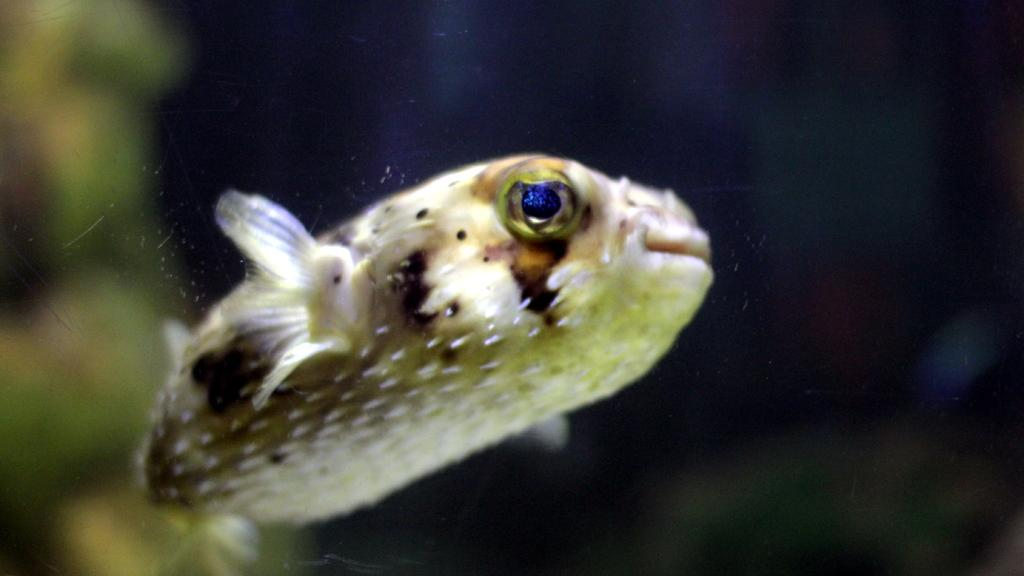What type of animal can be seen in the image? There is an aquatic animal in the image. Where is the aquatic animal located? The aquatic animal is in the water. Can you describe the background of the image? The background of the image is blurred. What type of trucks can be seen in the image? There are no trucks present in the image; it features an aquatic animal in the water. How many birds are in the flock in the image? There is no flock of birds present in the image; it features an aquatic animal in the water. 